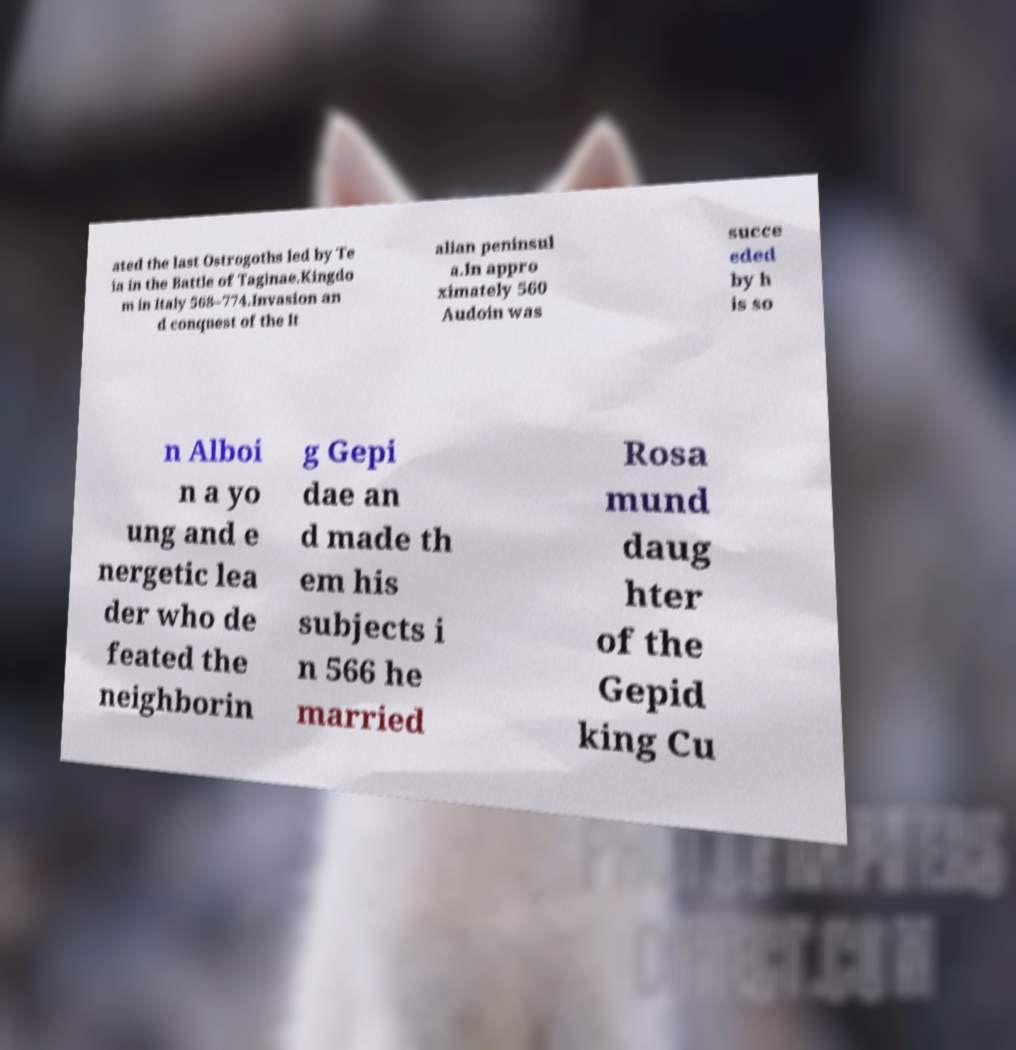Can you read and provide the text displayed in the image?This photo seems to have some interesting text. Can you extract and type it out for me? ated the last Ostrogoths led by Te ia in the Battle of Taginae.Kingdo m in Italy 568–774.Invasion an d conquest of the It alian peninsul a.In appro ximately 560 Audoin was succe eded by h is so n Alboi n a yo ung and e nergetic lea der who de feated the neighborin g Gepi dae an d made th em his subjects i n 566 he married Rosa mund daug hter of the Gepid king Cu 